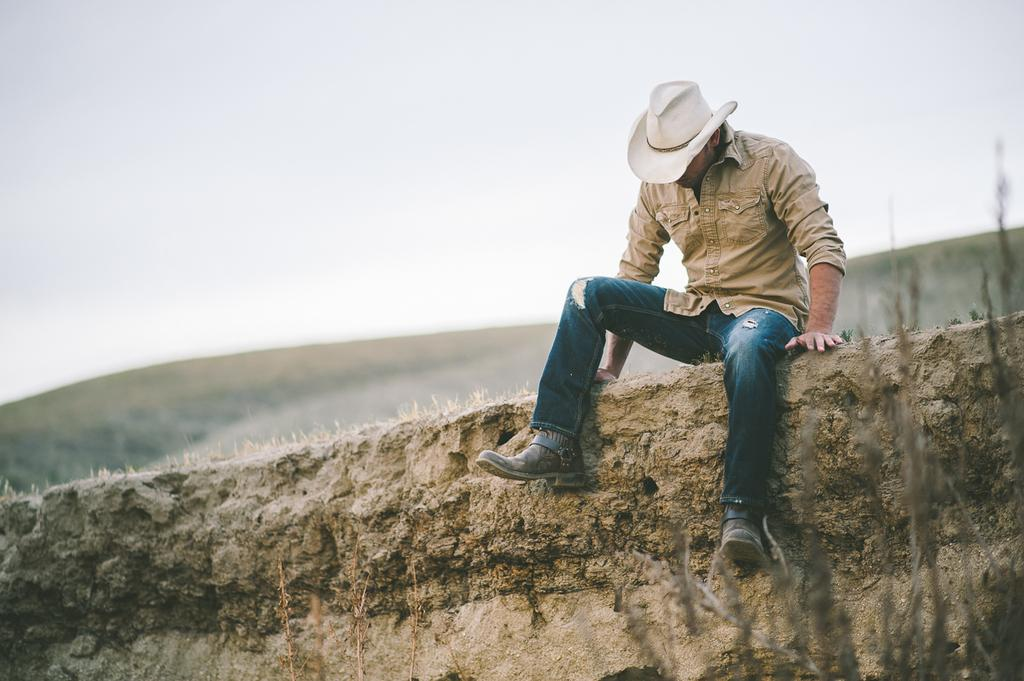What is the setting of the image? The image is an outside view. Can you describe the man's position in the image? There is a man sitting on a wall on the right side of the image. What is the man doing in the image? The man is looking downwards. What can be seen at the top of the image? The sky is visible at the top of the image. What book is the man reading in the image? There is no book present in the image; the man is simply sitting on a wall and looking downwards. 